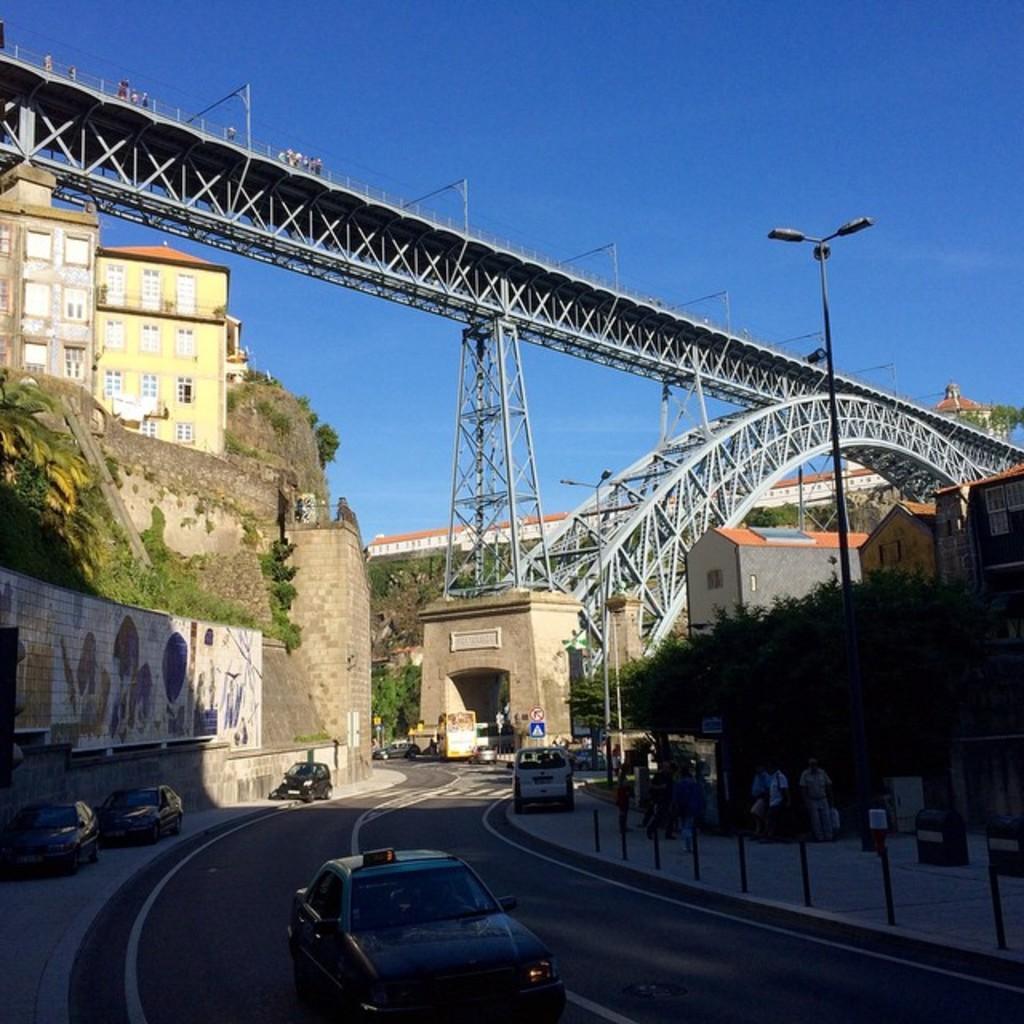Describe this image in one or two sentences. In this picture I can see the vehicles on the road. I can see the bridge. I can see some vehicles on the walkway. I can see some people on the walkway. I can see trees on the right side. I can see the buildings. 